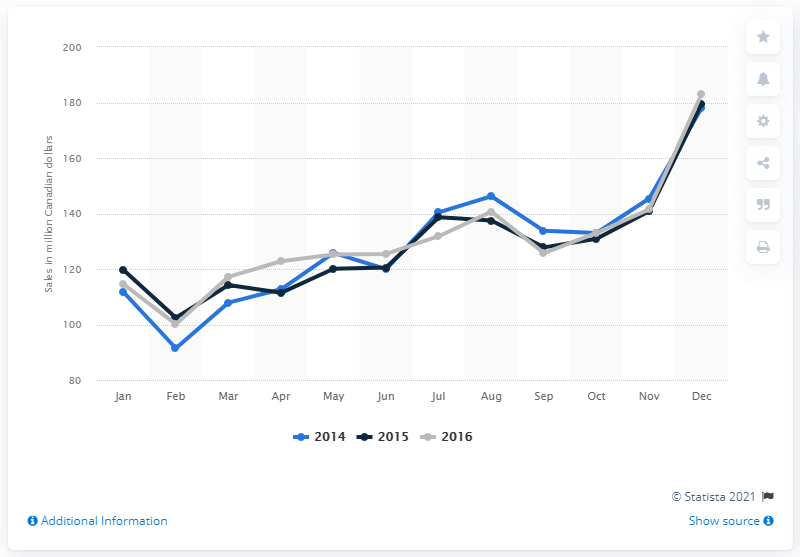Specify some key components in this picture. In December 2014, the retail sales of bedding, linens and bathroom accessories in Canada totaled 178.12. 